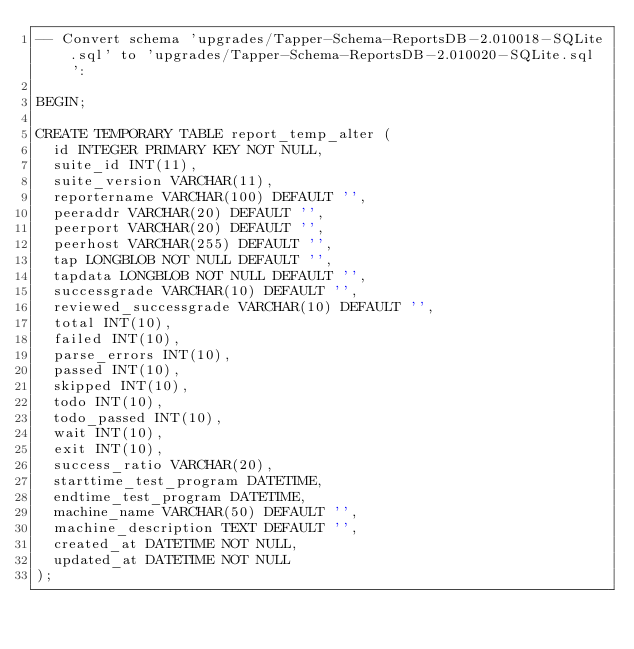Convert code to text. <code><loc_0><loc_0><loc_500><loc_500><_SQL_>-- Convert schema 'upgrades/Tapper-Schema-ReportsDB-2.010018-SQLite.sql' to 'upgrades/Tapper-Schema-ReportsDB-2.010020-SQLite.sql':

BEGIN;

CREATE TEMPORARY TABLE report_temp_alter (
  id INTEGER PRIMARY KEY NOT NULL,
  suite_id INT(11),
  suite_version VARCHAR(11),
  reportername VARCHAR(100) DEFAULT '',
  peeraddr VARCHAR(20) DEFAULT '',
  peerport VARCHAR(20) DEFAULT '',
  peerhost VARCHAR(255) DEFAULT '',
  tap LONGBLOB NOT NULL DEFAULT '',
  tapdata LONGBLOB NOT NULL DEFAULT '',
  successgrade VARCHAR(10) DEFAULT '',
  reviewed_successgrade VARCHAR(10) DEFAULT '',
  total INT(10),
  failed INT(10),
  parse_errors INT(10),
  passed INT(10),
  skipped INT(10),
  todo INT(10),
  todo_passed INT(10),
  wait INT(10),
  exit INT(10),
  success_ratio VARCHAR(20),
  starttime_test_program DATETIME,
  endtime_test_program DATETIME,
  machine_name VARCHAR(50) DEFAULT '',
  machine_description TEXT DEFAULT '',
  created_at DATETIME NOT NULL,
  updated_at DATETIME NOT NULL
);</code> 